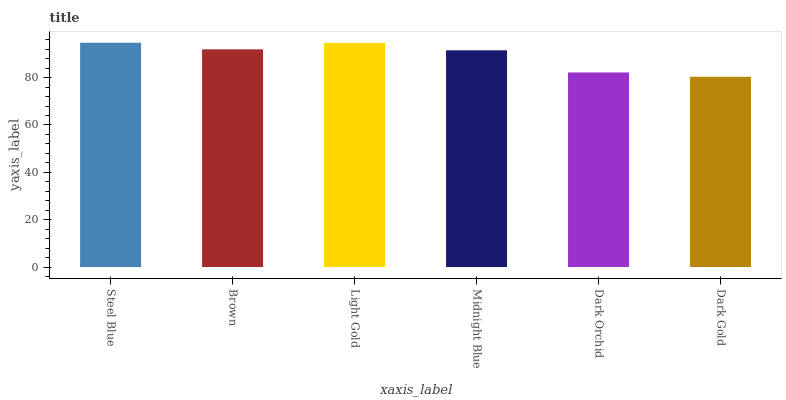Is Dark Gold the minimum?
Answer yes or no. Yes. Is Steel Blue the maximum?
Answer yes or no. Yes. Is Brown the minimum?
Answer yes or no. No. Is Brown the maximum?
Answer yes or no. No. Is Steel Blue greater than Brown?
Answer yes or no. Yes. Is Brown less than Steel Blue?
Answer yes or no. Yes. Is Brown greater than Steel Blue?
Answer yes or no. No. Is Steel Blue less than Brown?
Answer yes or no. No. Is Brown the high median?
Answer yes or no. Yes. Is Midnight Blue the low median?
Answer yes or no. Yes. Is Midnight Blue the high median?
Answer yes or no. No. Is Steel Blue the low median?
Answer yes or no. No. 